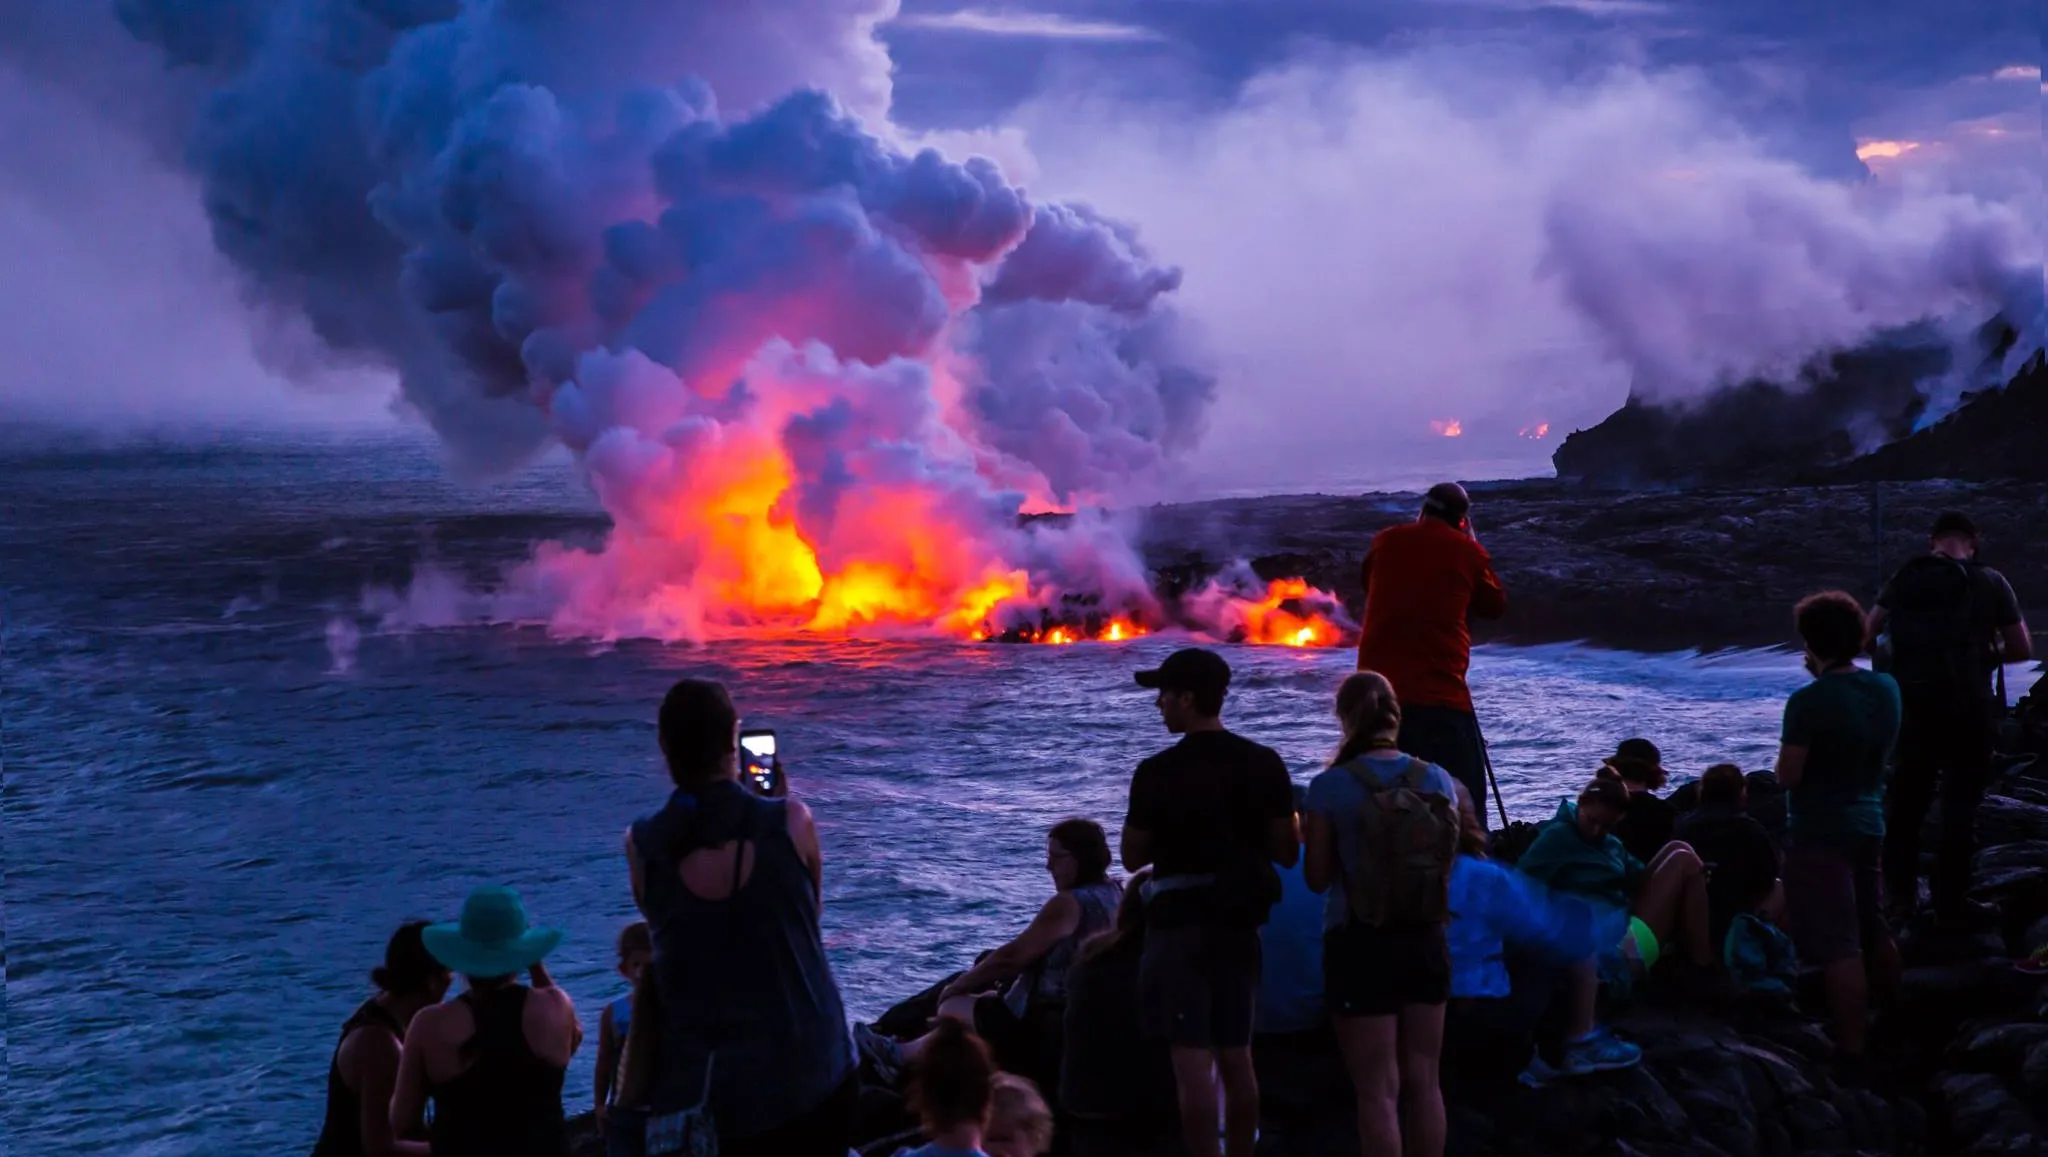Can you tell me what process is occurring as the lava cools when it meets the ocean? When lava meets ocean water, a rapid cooling process occurs. This interaction generates steam and volcanic glass, and the quick solidification of lava creates new landforms, such as deltas. This process is a dramatic example of igneous rock formation and showcases the dynamic interactions between geologic and oceanographic processes. 